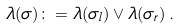Convert formula to latex. <formula><loc_0><loc_0><loc_500><loc_500>\lambda ( \sigma ) \colon = \lambda ( \sigma _ { l } ) \vee \lambda ( \sigma _ { r } ) \, .</formula> 